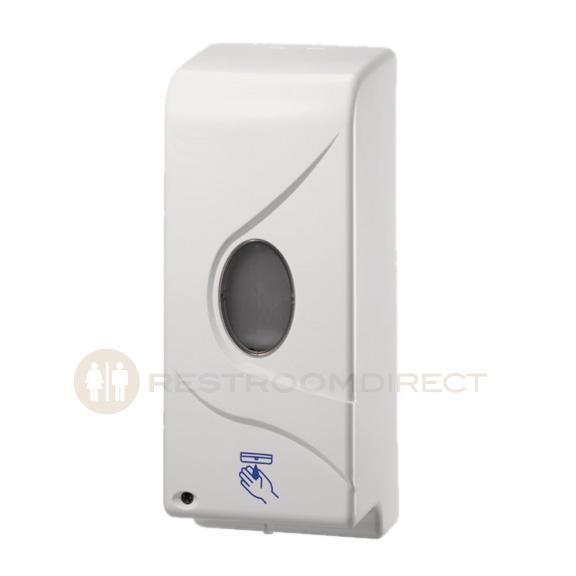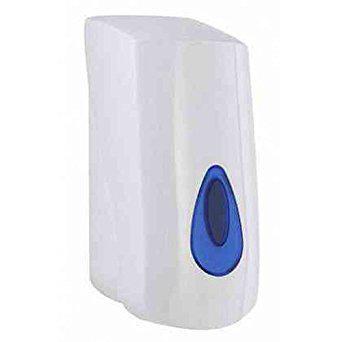The first image is the image on the left, the second image is the image on the right. Assess this claim about the two images: "At least one of the soap dispensers is not white.". Correct or not? Answer yes or no. No. The first image is the image on the left, the second image is the image on the right. Assess this claim about the two images: "All of the soap dispensers are primarily white.". Correct or not? Answer yes or no. Yes. 